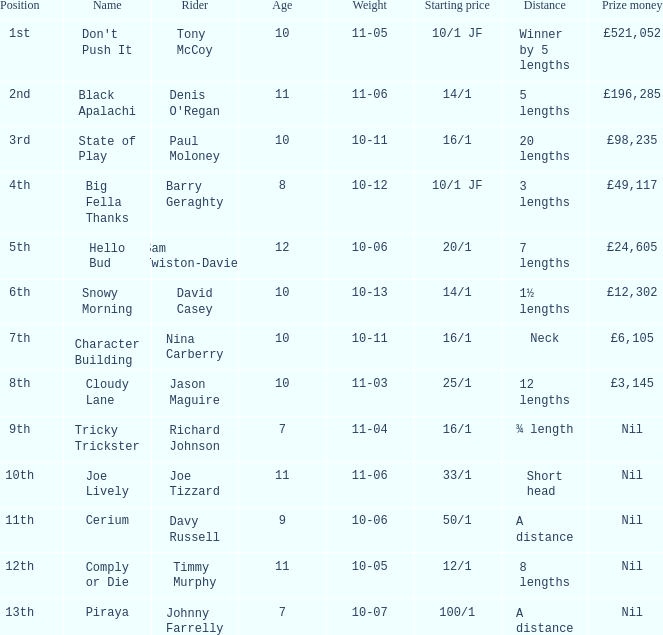What sum did nina carberry gain? £6,105. 